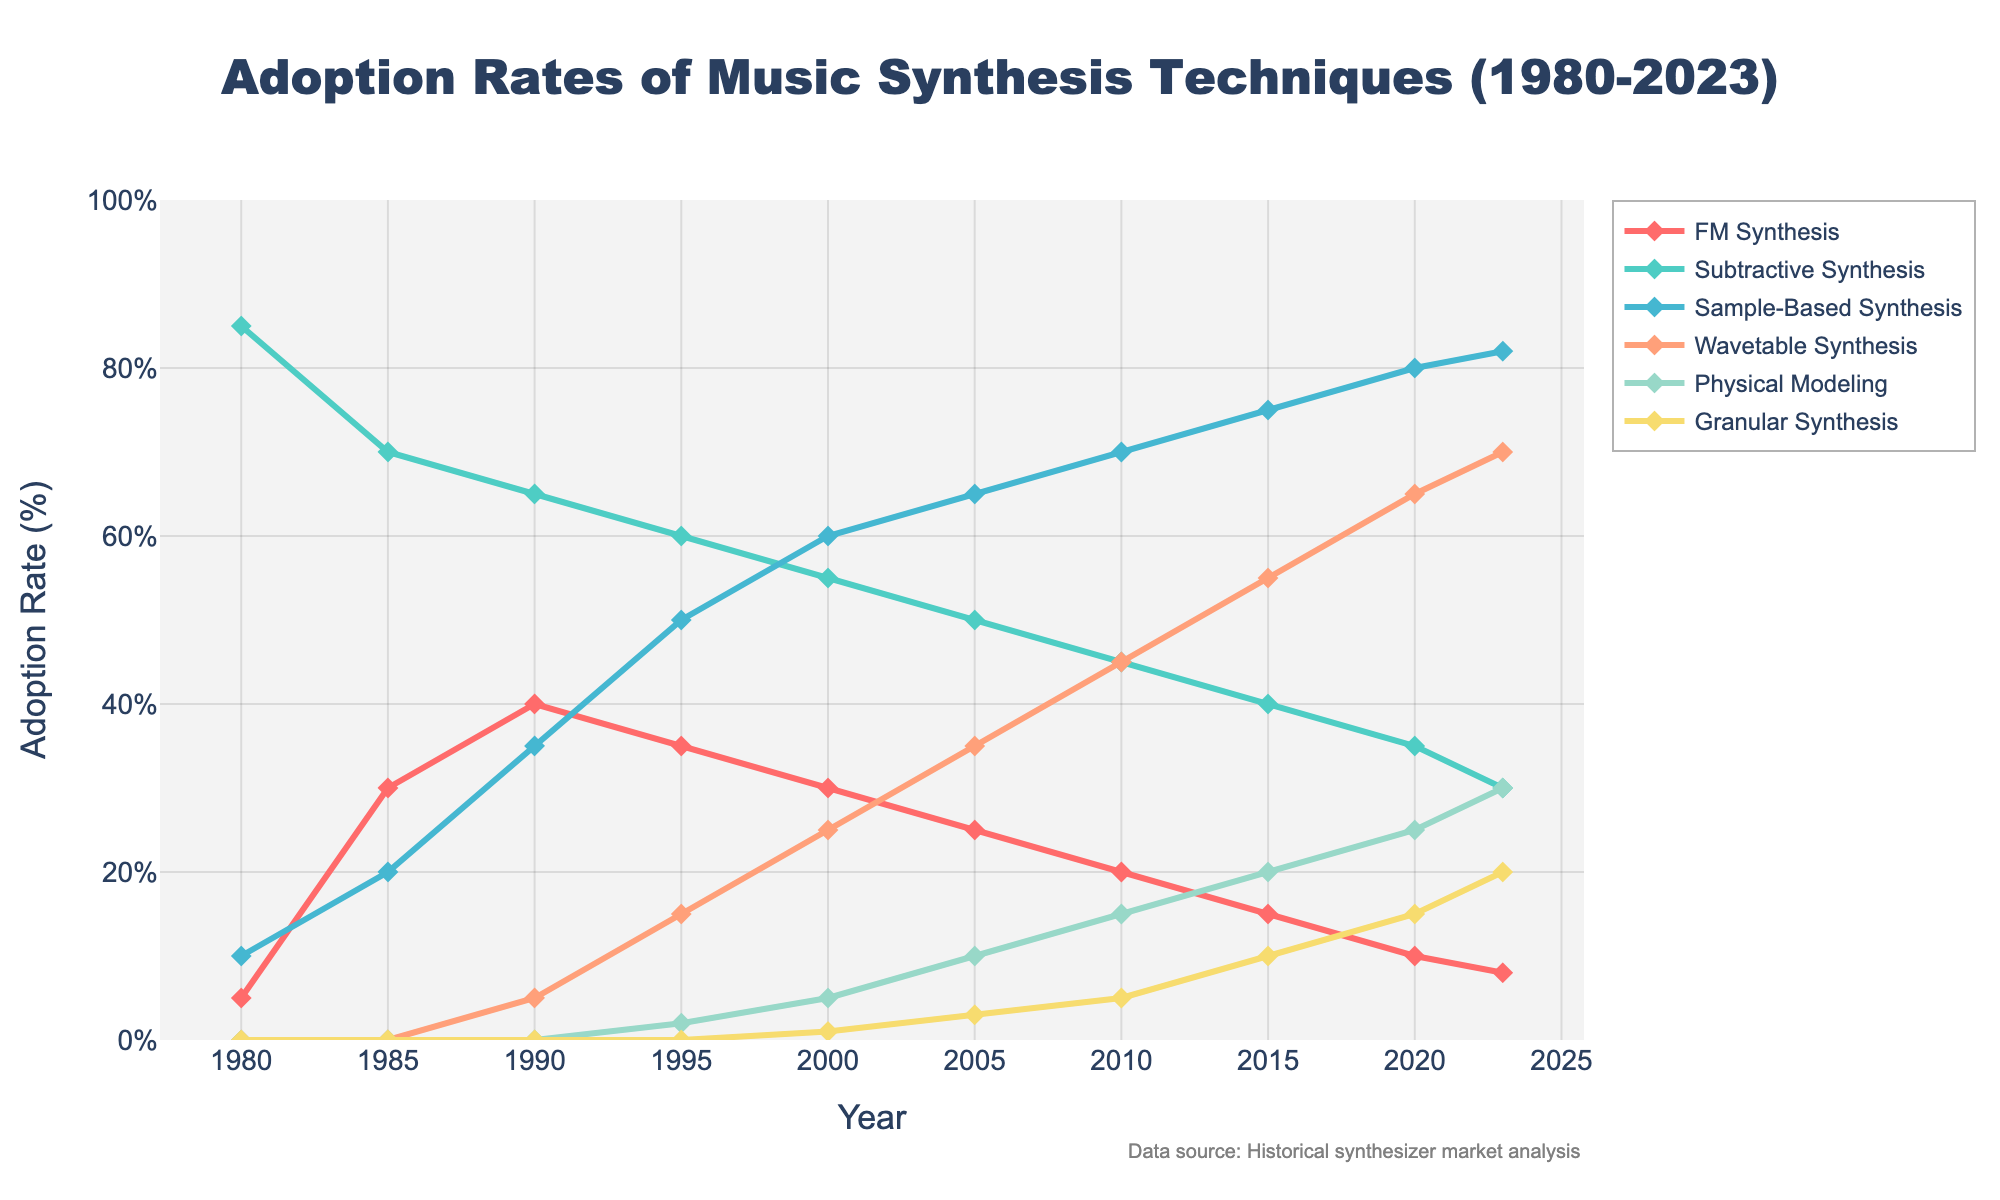What is the adoption rate of FM Synthesis in 2005 minus the adoption rate of Wavetable Synthesis in the same year? To find the difference, refer to the adoption rates for FM Synthesis and Wavetable Synthesis in 2005. FM Synthesis has an adoption rate of 25%, and Wavetable Synthesis has an adoption rate of 35%. Subtract 35 from 25: 25% - 35% = -10%.
Answer: -10% Which synthesis technique had the highest adoption rate in 2023? Look at the adoption rates for all synthesis techniques in 2023. Subtractive Synthesis has an adoption rate of 30%, which is lower than Wavetable Synthesis at 70% and Sample-Based Synthesis at 82%, making Sample-Based Synthesis the highest.
Answer: Sample-Based Synthesis How many years did FM Synthesis have an adoption rate higher than 20%? Scan the line for FM Synthesis and count the years where the rate exceeds 20%. These years are 1985 (30%), 1990 (40%), 1995 (35%), and 2000 (30%). So, it spans 4 years.
Answer: 4 years What is the average adoption rate of Granular Synthesis from 2010 to 2023? To find the average, add the adoption rates for Granular Synthesis from years 2010, 2015, 2020, and 2023: 5% + 10% + 15% + 20% = 50%. Then divide by 4 (number of years): 50% / 4 = 12.5%.
Answer: 12.5% What was the overall trend of Subtractive Synthesis adoption from 1980 to 2023? Look at the curve for Subtractive Synthesis from 1980 (85%) to 2023 (30%). The trend shows a continuous decline.
Answer: Decline Which year shows the highest increase in adoption rate for Sample-Based Synthesis compared to the previous year? Compare the yearly increases for Sample-Based Synthesis: 1985 (10%), 1990 (15%), 1995 (15%), 2000 (10%), 2005 (5%), 2010 (5%), 2015 (5%), 2020 (5%), 2023 (2%). The highest increase is between 1985 and 1990, which is 15%.
Answer: 1990 Are there any years where the adoption rate of Physical Modeling equaled that of Granular Synthesis? Compare the corresponding years for both techniques. In 1995, Physical Modeling is at 2% while Granular Synthesis is at 0%. The rates do not match in any year, not even in the following years.
Answer: No What is the cumulative adoption rate of Subtractive Synthesis and Sample-Based Synthesis for the year 2010? Add the adoption rates for Subtractive Synthesis (45%) and Sample-Based Synthesis (70%) for 2010: 45% + 70% = 115%.
Answer: 115% Between 1985 and 2005, by how much did the adoption rate of Wavetable Synthesis increase? Check the adoption rates in 1985 (0%) and 2005 (35%) for Wavetable Synthesis. The increase is: 35% - 0% = 35%.
Answer: 35% 